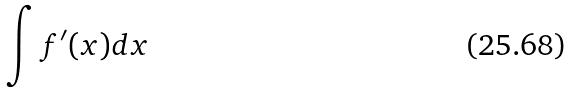<formula> <loc_0><loc_0><loc_500><loc_500>\int f ^ { \prime } ( x ) d x</formula> 